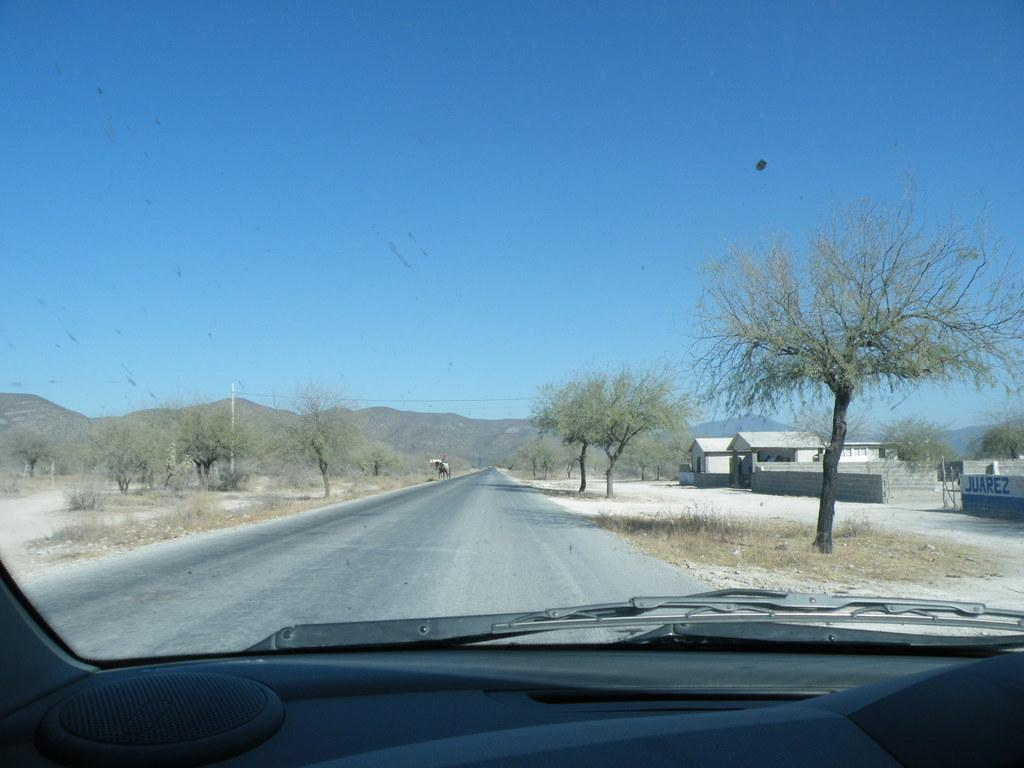What type of vegetation can be seen on both sides of the image? There are trees on both the right and left sides of the image. What is the main feature visible in the middle of the image? There is a road visible in the image. What type of structures can be seen on the right side of the image? There are houses on the right side of the image. What natural feature is visible in the background of the image? There are mountains visible in the image. What is present in the sky in the image? Clouds are present in the sky. What letter is carved into the side of the mountain in the image? There is no letter carved into the side of the mountain in the image. What type of material is the cork made of in the image? There is no cork present in the image. 